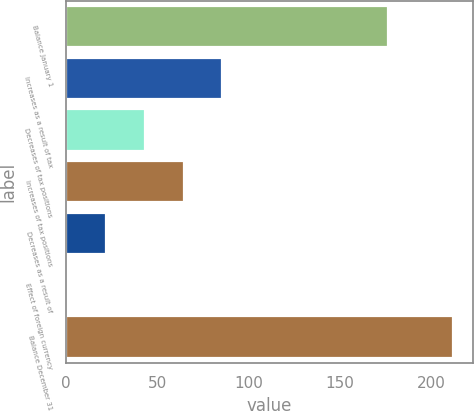Convert chart. <chart><loc_0><loc_0><loc_500><loc_500><bar_chart><fcel>Balance January 1<fcel>Increases as a result of tax<fcel>Decreases of tax positions<fcel>Increases of tax positions<fcel>Decreases as a result of<fcel>Effect of foreign currency<fcel>Balance December 31<nl><fcel>176<fcel>85.4<fcel>43.2<fcel>64.3<fcel>22.1<fcel>1<fcel>212<nl></chart> 